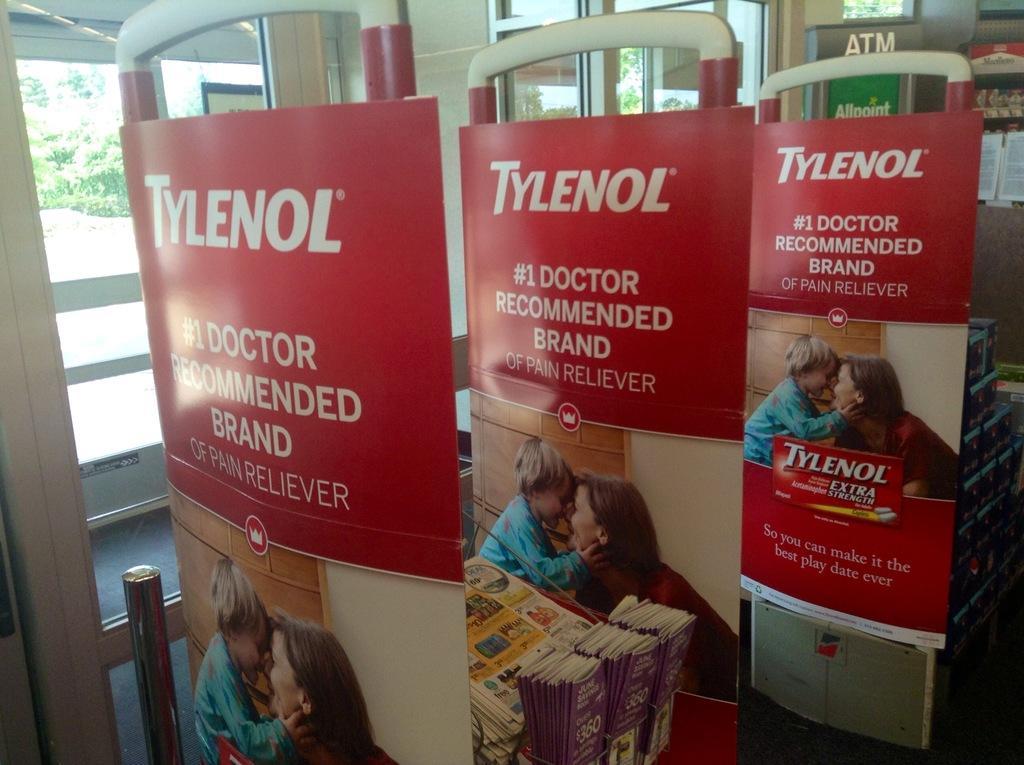Could you give a brief overview of what you see in this image? In this picture we can see a few banners. In these banners, we can see an image of a woman and a child. There is some text on these banners. We can see some books and newspapers. There are a few boxes and other objects in the background. We can see a glass. Through this glass, we can see a few trees in the background. 